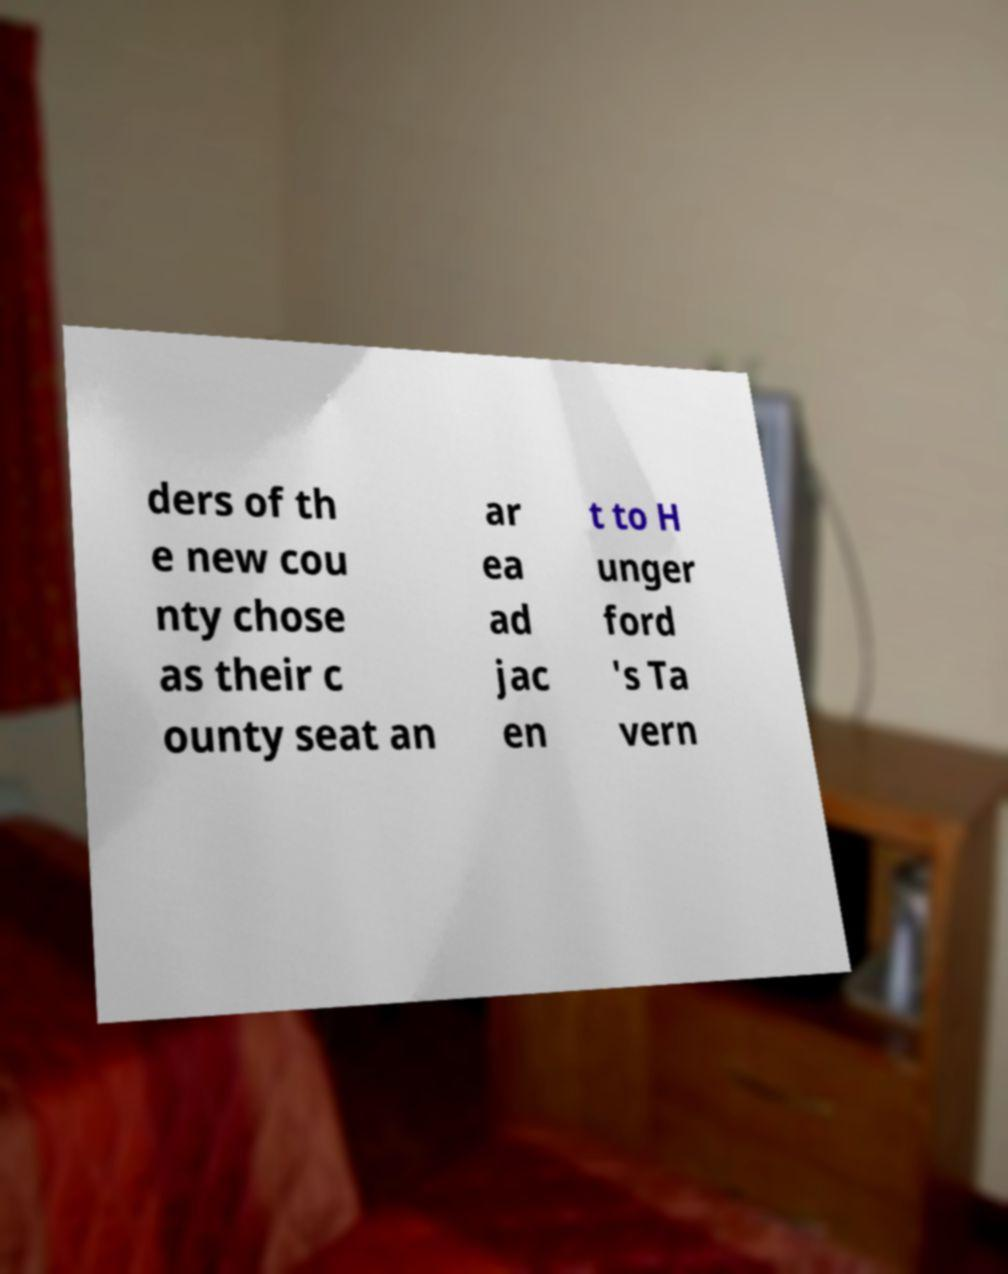Could you assist in decoding the text presented in this image and type it out clearly? ders of th e new cou nty chose as their c ounty seat an ar ea ad jac en t to H unger ford 's Ta vern 